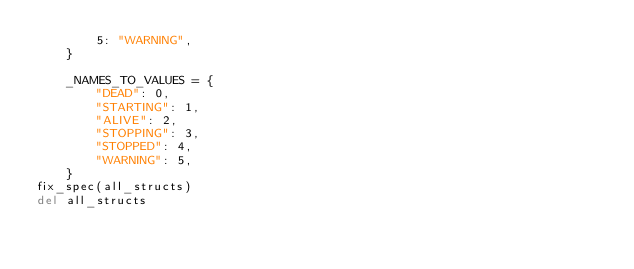Convert code to text. <code><loc_0><loc_0><loc_500><loc_500><_Python_>        5: "WARNING",
    }

    _NAMES_TO_VALUES = {
        "DEAD": 0,
        "STARTING": 1,
        "ALIVE": 2,
        "STOPPING": 3,
        "STOPPED": 4,
        "WARNING": 5,
    }
fix_spec(all_structs)
del all_structs
</code> 